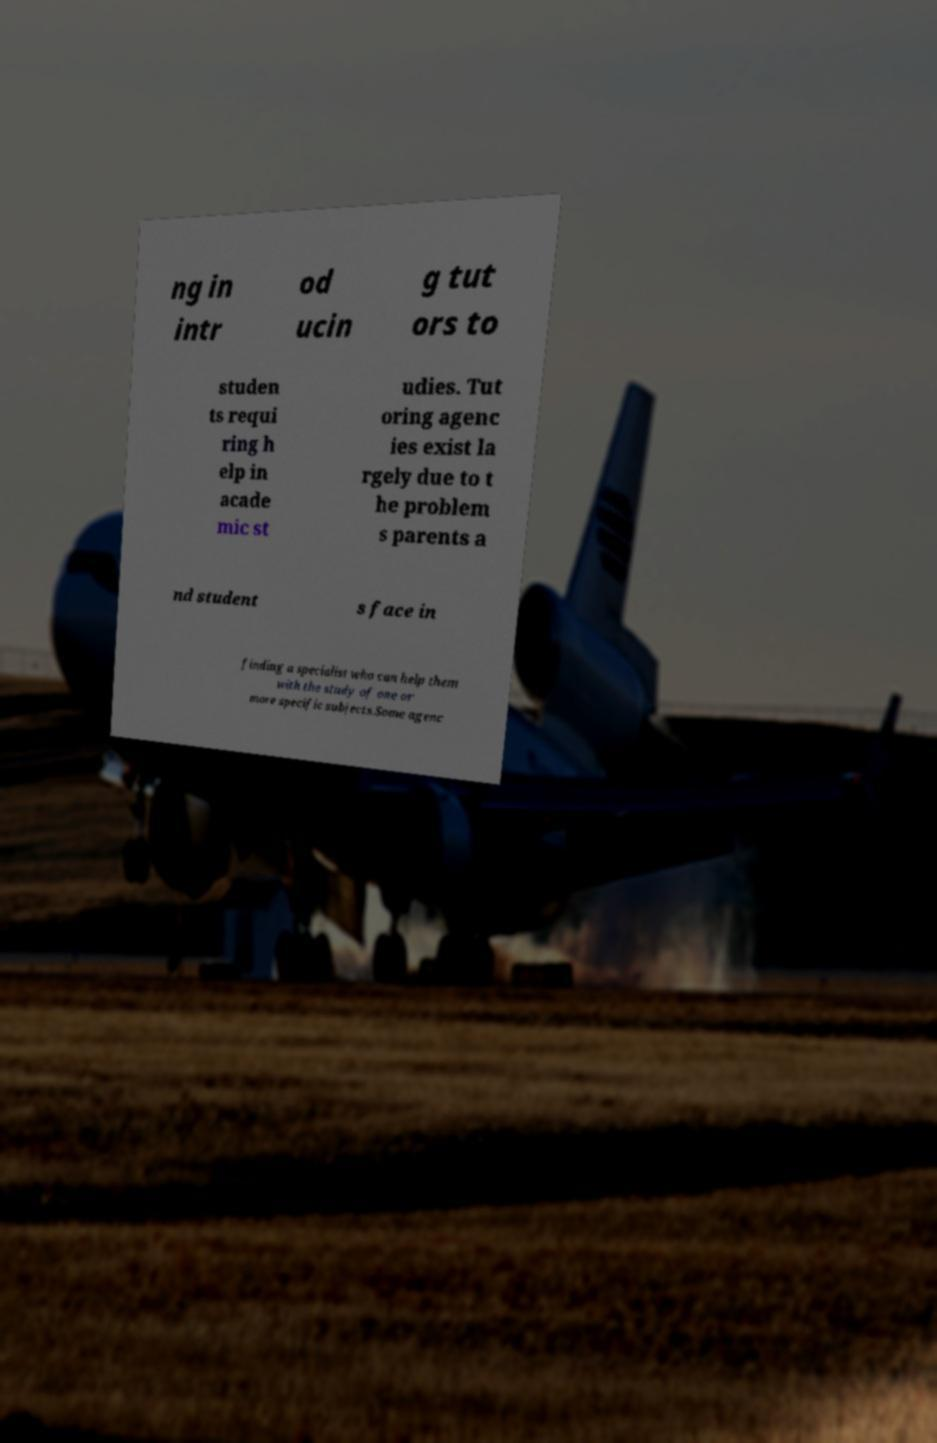For documentation purposes, I need the text within this image transcribed. Could you provide that? ng in intr od ucin g tut ors to studen ts requi ring h elp in acade mic st udies. Tut oring agenc ies exist la rgely due to t he problem s parents a nd student s face in finding a specialist who can help them with the study of one or more specific subjects.Some agenc 